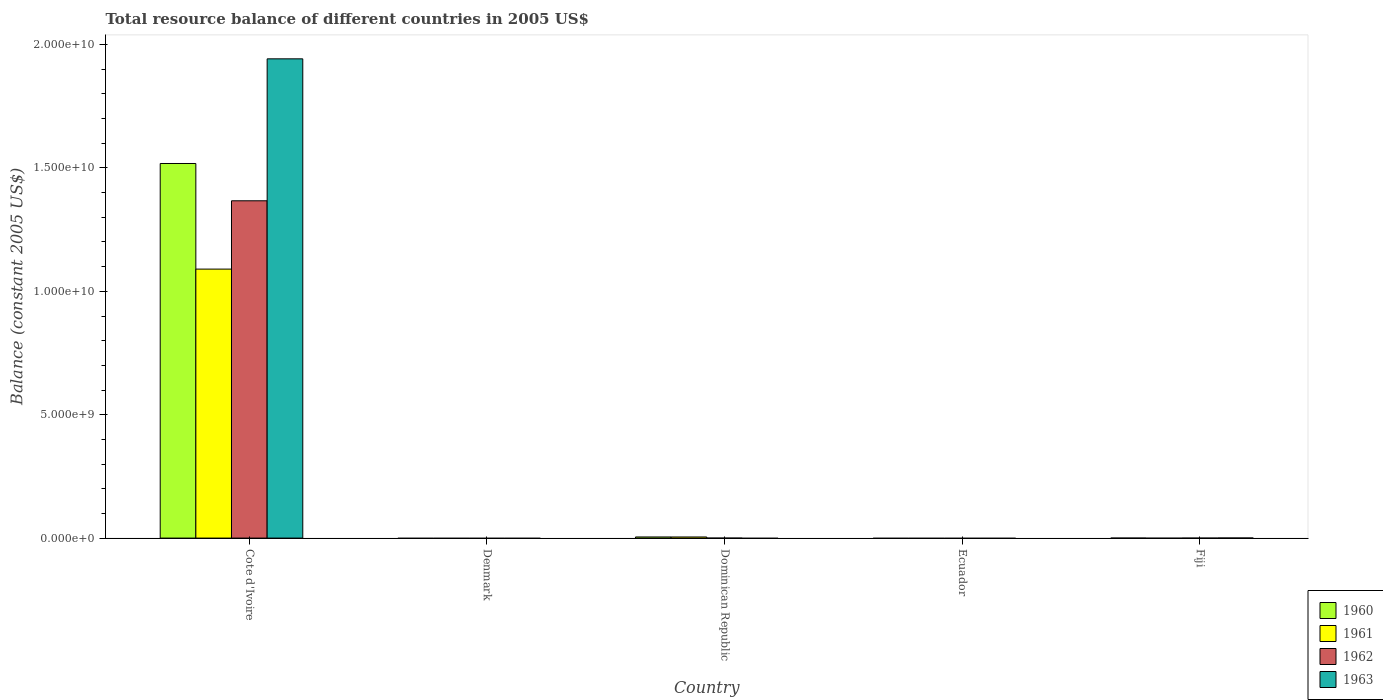How many different coloured bars are there?
Keep it short and to the point. 4. Are the number of bars per tick equal to the number of legend labels?
Provide a short and direct response. No. Are the number of bars on each tick of the X-axis equal?
Offer a very short reply. No. What is the label of the 2nd group of bars from the left?
Your answer should be very brief. Denmark. Across all countries, what is the maximum total resource balance in 1960?
Your answer should be very brief. 1.52e+1. In which country was the total resource balance in 1963 maximum?
Your answer should be compact. Cote d'Ivoire. What is the total total resource balance in 1960 in the graph?
Provide a succinct answer. 1.52e+1. What is the difference between the total resource balance in 1961 in Cote d'Ivoire and that in Dominican Republic?
Offer a very short reply. 1.09e+1. What is the difference between the total resource balance in 1962 in Denmark and the total resource balance in 1960 in Dominican Republic?
Give a very brief answer. -4.56e+07. What is the average total resource balance in 1962 per country?
Your answer should be very brief. 2.73e+09. What is the difference between the total resource balance of/in 1962 and total resource balance of/in 1963 in Cote d'Ivoire?
Your answer should be compact. -5.75e+09. What is the ratio of the total resource balance in 1960 in Cote d'Ivoire to that in Dominican Republic?
Ensure brevity in your answer.  332.91. What is the difference between the highest and the lowest total resource balance in 1961?
Offer a very short reply. 1.09e+1. How many bars are there?
Provide a succinct answer. 7. How many countries are there in the graph?
Offer a very short reply. 5. Are the values on the major ticks of Y-axis written in scientific E-notation?
Your answer should be very brief. Yes. How many legend labels are there?
Your answer should be very brief. 4. What is the title of the graph?
Your answer should be very brief. Total resource balance of different countries in 2005 US$. What is the label or title of the X-axis?
Offer a terse response. Country. What is the label or title of the Y-axis?
Provide a short and direct response. Balance (constant 2005 US$). What is the Balance (constant 2005 US$) in 1960 in Cote d'Ivoire?
Give a very brief answer. 1.52e+1. What is the Balance (constant 2005 US$) of 1961 in Cote d'Ivoire?
Make the answer very short. 1.09e+1. What is the Balance (constant 2005 US$) of 1962 in Cote d'Ivoire?
Your answer should be compact. 1.37e+1. What is the Balance (constant 2005 US$) of 1963 in Cote d'Ivoire?
Ensure brevity in your answer.  1.94e+1. What is the Balance (constant 2005 US$) in 1962 in Denmark?
Keep it short and to the point. 0. What is the Balance (constant 2005 US$) in 1960 in Dominican Republic?
Provide a succinct answer. 4.56e+07. What is the Balance (constant 2005 US$) of 1961 in Dominican Republic?
Offer a terse response. 4.52e+07. What is the Balance (constant 2005 US$) of 1962 in Dominican Republic?
Offer a terse response. 0. What is the Balance (constant 2005 US$) of 1963 in Dominican Republic?
Your answer should be very brief. 0. What is the Balance (constant 2005 US$) of 1962 in Ecuador?
Your response must be concise. 0. What is the Balance (constant 2005 US$) in 1963 in Ecuador?
Your response must be concise. 0. What is the Balance (constant 2005 US$) of 1960 in Fiji?
Ensure brevity in your answer.  0. What is the Balance (constant 2005 US$) of 1963 in Fiji?
Offer a very short reply. 2.50e+06. Across all countries, what is the maximum Balance (constant 2005 US$) of 1960?
Keep it short and to the point. 1.52e+1. Across all countries, what is the maximum Balance (constant 2005 US$) in 1961?
Give a very brief answer. 1.09e+1. Across all countries, what is the maximum Balance (constant 2005 US$) in 1962?
Ensure brevity in your answer.  1.37e+1. Across all countries, what is the maximum Balance (constant 2005 US$) of 1963?
Ensure brevity in your answer.  1.94e+1. Across all countries, what is the minimum Balance (constant 2005 US$) of 1960?
Ensure brevity in your answer.  0. Across all countries, what is the minimum Balance (constant 2005 US$) of 1961?
Offer a very short reply. 0. What is the total Balance (constant 2005 US$) in 1960 in the graph?
Offer a very short reply. 1.52e+1. What is the total Balance (constant 2005 US$) in 1961 in the graph?
Offer a terse response. 1.09e+1. What is the total Balance (constant 2005 US$) in 1962 in the graph?
Your response must be concise. 1.37e+1. What is the total Balance (constant 2005 US$) of 1963 in the graph?
Keep it short and to the point. 1.94e+1. What is the difference between the Balance (constant 2005 US$) in 1960 in Cote d'Ivoire and that in Dominican Republic?
Your answer should be compact. 1.51e+1. What is the difference between the Balance (constant 2005 US$) of 1961 in Cote d'Ivoire and that in Dominican Republic?
Make the answer very short. 1.09e+1. What is the difference between the Balance (constant 2005 US$) of 1963 in Cote d'Ivoire and that in Fiji?
Make the answer very short. 1.94e+1. What is the difference between the Balance (constant 2005 US$) of 1960 in Cote d'Ivoire and the Balance (constant 2005 US$) of 1961 in Dominican Republic?
Provide a short and direct response. 1.51e+1. What is the difference between the Balance (constant 2005 US$) in 1960 in Cote d'Ivoire and the Balance (constant 2005 US$) in 1963 in Fiji?
Make the answer very short. 1.52e+1. What is the difference between the Balance (constant 2005 US$) in 1961 in Cote d'Ivoire and the Balance (constant 2005 US$) in 1963 in Fiji?
Your answer should be very brief. 1.09e+1. What is the difference between the Balance (constant 2005 US$) in 1962 in Cote d'Ivoire and the Balance (constant 2005 US$) in 1963 in Fiji?
Offer a terse response. 1.37e+1. What is the difference between the Balance (constant 2005 US$) in 1960 in Dominican Republic and the Balance (constant 2005 US$) in 1963 in Fiji?
Make the answer very short. 4.31e+07. What is the difference between the Balance (constant 2005 US$) in 1961 in Dominican Republic and the Balance (constant 2005 US$) in 1963 in Fiji?
Your response must be concise. 4.27e+07. What is the average Balance (constant 2005 US$) in 1960 per country?
Keep it short and to the point. 3.05e+09. What is the average Balance (constant 2005 US$) in 1961 per country?
Offer a terse response. 2.19e+09. What is the average Balance (constant 2005 US$) of 1962 per country?
Your response must be concise. 2.73e+09. What is the average Balance (constant 2005 US$) in 1963 per country?
Your response must be concise. 3.88e+09. What is the difference between the Balance (constant 2005 US$) of 1960 and Balance (constant 2005 US$) of 1961 in Cote d'Ivoire?
Offer a very short reply. 4.28e+09. What is the difference between the Balance (constant 2005 US$) of 1960 and Balance (constant 2005 US$) of 1962 in Cote d'Ivoire?
Your answer should be very brief. 1.51e+09. What is the difference between the Balance (constant 2005 US$) in 1960 and Balance (constant 2005 US$) in 1963 in Cote d'Ivoire?
Make the answer very short. -4.24e+09. What is the difference between the Balance (constant 2005 US$) in 1961 and Balance (constant 2005 US$) in 1962 in Cote d'Ivoire?
Make the answer very short. -2.77e+09. What is the difference between the Balance (constant 2005 US$) of 1961 and Balance (constant 2005 US$) of 1963 in Cote d'Ivoire?
Provide a short and direct response. -8.52e+09. What is the difference between the Balance (constant 2005 US$) of 1962 and Balance (constant 2005 US$) of 1963 in Cote d'Ivoire?
Provide a succinct answer. -5.75e+09. What is the ratio of the Balance (constant 2005 US$) in 1960 in Cote d'Ivoire to that in Dominican Republic?
Provide a short and direct response. 332.91. What is the ratio of the Balance (constant 2005 US$) of 1961 in Cote d'Ivoire to that in Dominican Republic?
Provide a succinct answer. 241.17. What is the ratio of the Balance (constant 2005 US$) of 1963 in Cote d'Ivoire to that in Fiji?
Keep it short and to the point. 7768.74. What is the difference between the highest and the lowest Balance (constant 2005 US$) in 1960?
Your response must be concise. 1.52e+1. What is the difference between the highest and the lowest Balance (constant 2005 US$) in 1961?
Offer a very short reply. 1.09e+1. What is the difference between the highest and the lowest Balance (constant 2005 US$) of 1962?
Offer a very short reply. 1.37e+1. What is the difference between the highest and the lowest Balance (constant 2005 US$) in 1963?
Your response must be concise. 1.94e+1. 